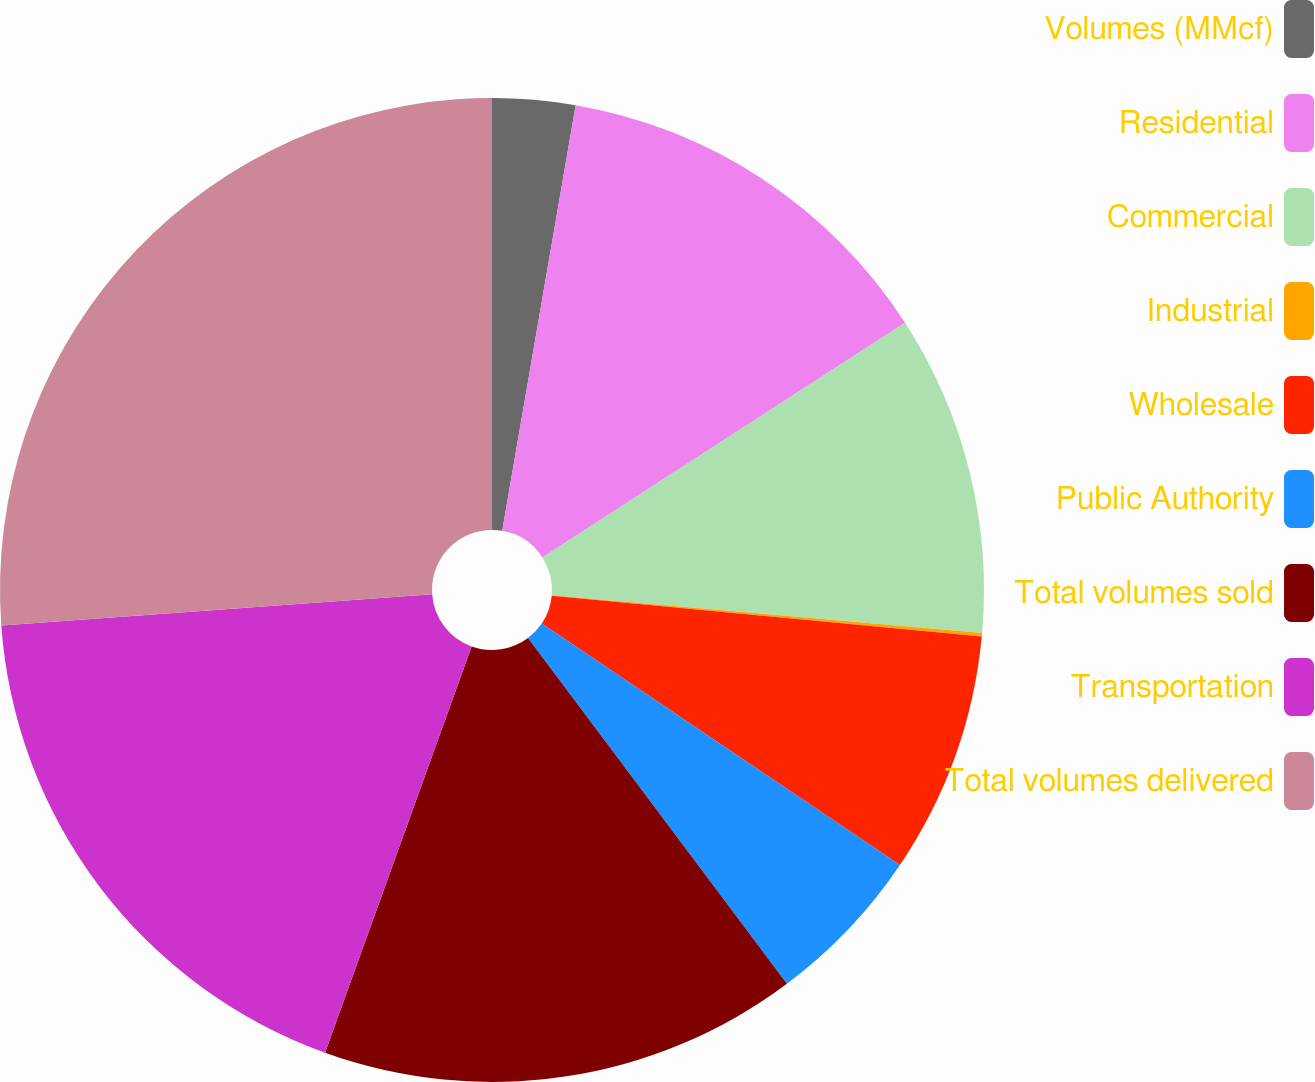<chart> <loc_0><loc_0><loc_500><loc_500><pie_chart><fcel>Volumes (MMcf)<fcel>Residential<fcel>Commercial<fcel>Industrial<fcel>Wholesale<fcel>Public Authority<fcel>Total volumes sold<fcel>Transportation<fcel>Total volumes delivered<nl><fcel>2.72%<fcel>13.14%<fcel>10.53%<fcel>0.12%<fcel>7.93%<fcel>5.33%<fcel>15.74%<fcel>18.34%<fcel>26.15%<nl></chart> 